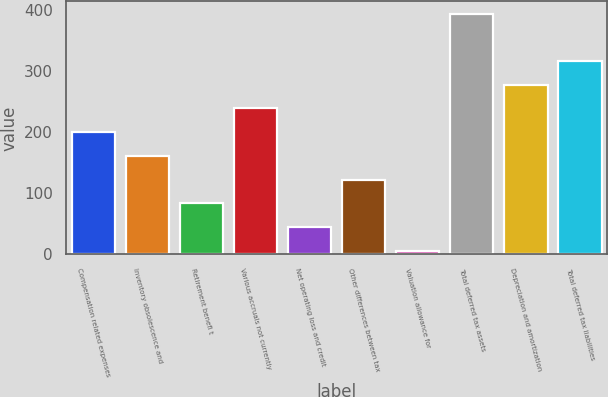Convert chart to OTSL. <chart><loc_0><loc_0><loc_500><loc_500><bar_chart><fcel>Compensation related expenses<fcel>Inventory obsolescence and<fcel>Retirement benefi t<fcel>Various accruals not currently<fcel>Net operating loss and credit<fcel>Other differences between tax<fcel>Valuation allowance for<fcel>Total deferred tax assets<fcel>Depreciation and amortization<fcel>Total deferred tax liabilities<nl><fcel>200.15<fcel>161.26<fcel>83.48<fcel>239.04<fcel>44.59<fcel>122.37<fcel>5.7<fcel>394.6<fcel>277.93<fcel>316.82<nl></chart> 